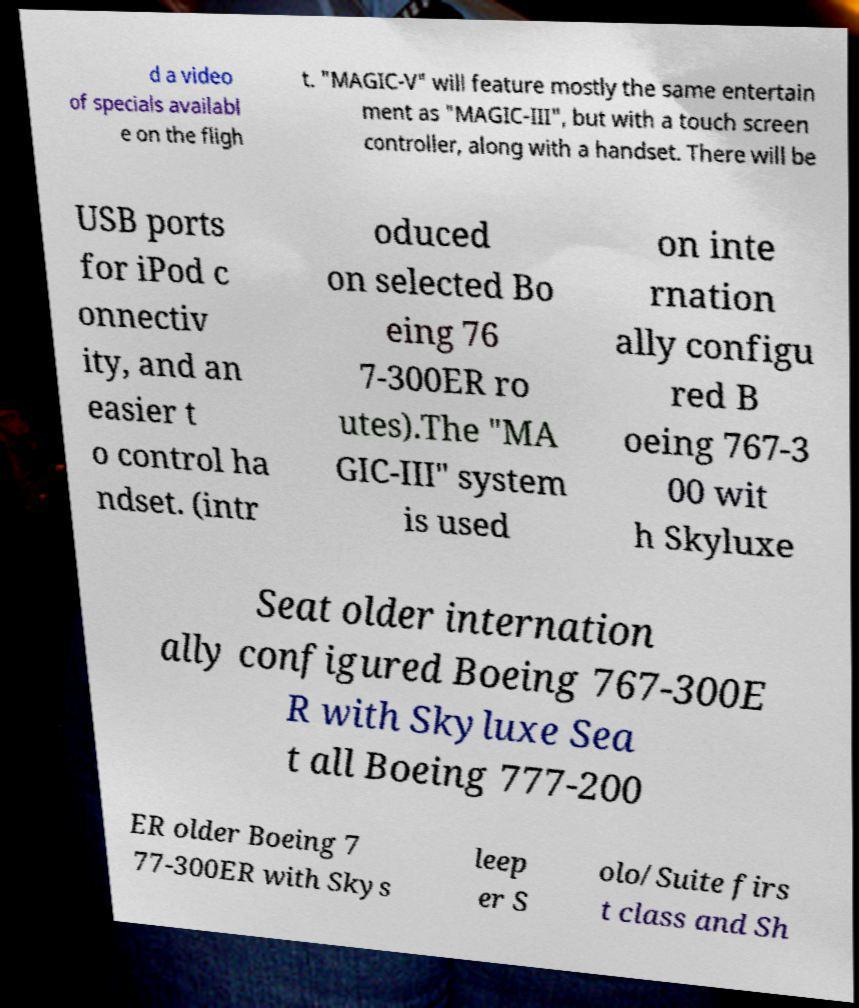Can you read and provide the text displayed in the image?This photo seems to have some interesting text. Can you extract and type it out for me? d a video of specials availabl e on the fligh t. "MAGIC-V" will feature mostly the same entertain ment as "MAGIC-III", but with a touch screen controller, along with a handset. There will be USB ports for iPod c onnectiv ity, and an easier t o control ha ndset. (intr oduced on selected Bo eing 76 7-300ER ro utes).The "MA GIC-III" system is used on inte rnation ally configu red B oeing 767-3 00 wit h Skyluxe Seat older internation ally configured Boeing 767-300E R with Skyluxe Sea t all Boeing 777-200 ER older Boeing 7 77-300ER with Skys leep er S olo/Suite firs t class and Sh 